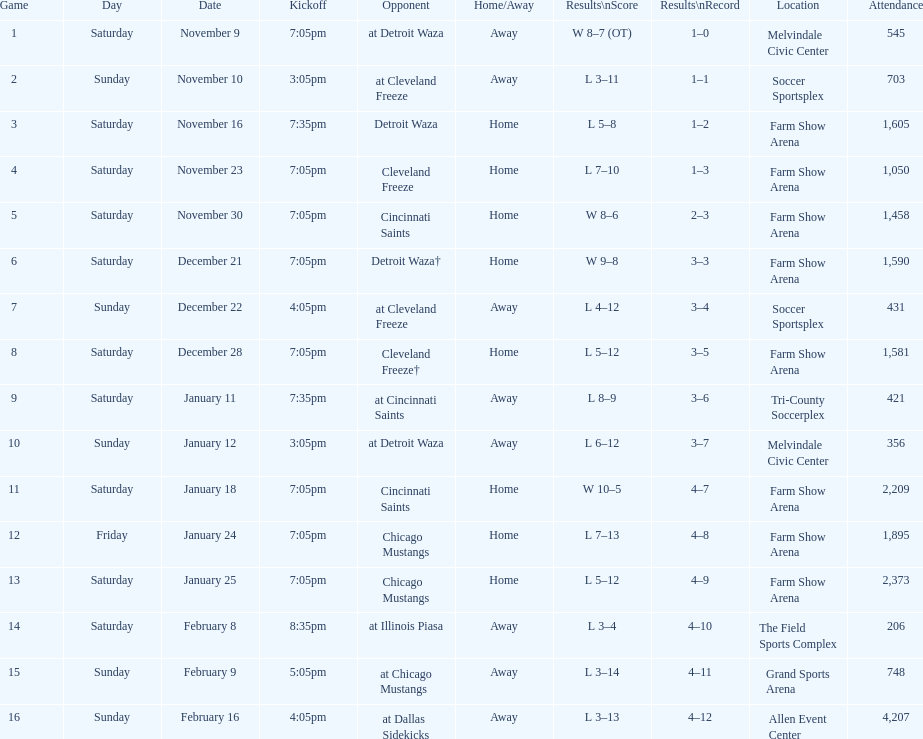How many games did the harrisburg heat win in which they scored eight or more goals? 4. 